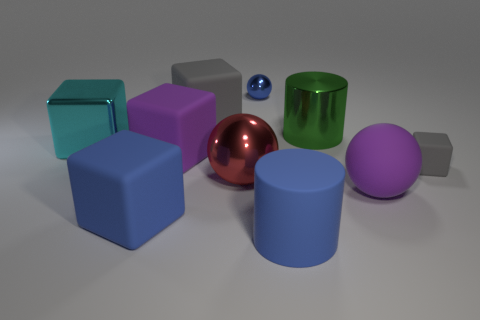There is a big block that is made of the same material as the red sphere; what color is it?
Provide a succinct answer. Cyan. How many blue balls have the same size as the green shiny cylinder?
Ensure brevity in your answer.  0. Does the tiny thing behind the big cyan metallic object have the same material as the big green thing?
Your answer should be compact. Yes. Is the number of cyan metallic cubes that are in front of the cyan block less than the number of blue metallic cylinders?
Your response must be concise. No. There is a tiny thing on the right side of the purple rubber ball; what is its shape?
Offer a terse response. Cube. The red object that is the same size as the green object is what shape?
Your response must be concise. Sphere. Are there any other shiny objects of the same shape as the tiny blue shiny thing?
Offer a very short reply. Yes. Does the large metallic thing left of the large gray block have the same shape as the gray object on the right side of the big purple rubber ball?
Offer a very short reply. Yes. There is a gray block that is the same size as the rubber ball; what is its material?
Provide a succinct answer. Rubber. What number of other things are the same material as the large gray thing?
Give a very brief answer. 5. 